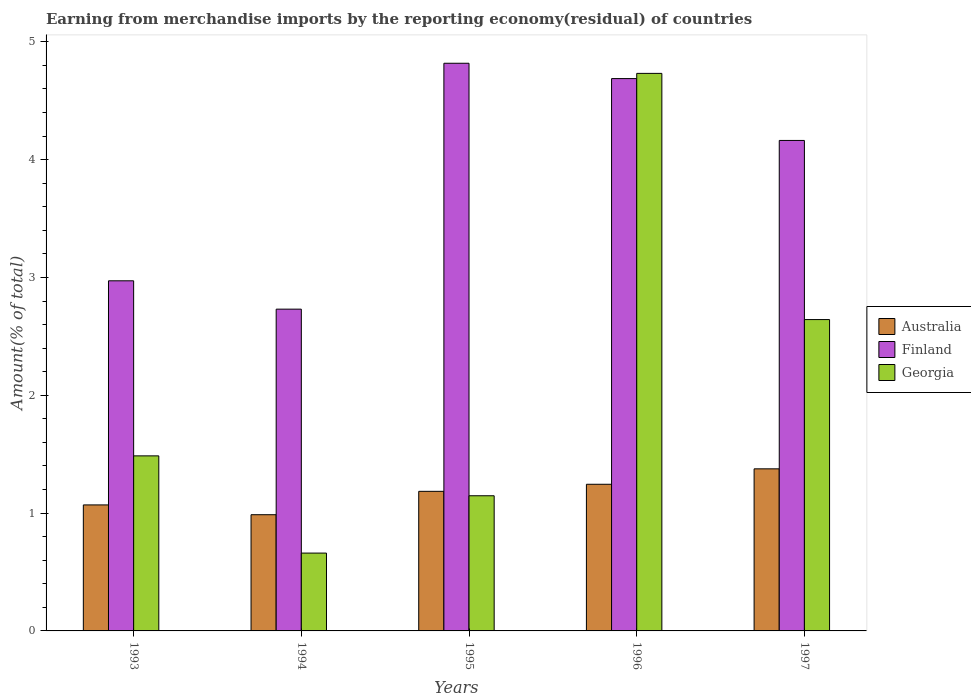How many groups of bars are there?
Your answer should be compact. 5. Are the number of bars per tick equal to the number of legend labels?
Make the answer very short. Yes. How many bars are there on the 1st tick from the left?
Your answer should be very brief. 3. How many bars are there on the 5th tick from the right?
Your response must be concise. 3. What is the percentage of amount earned from merchandise imports in Australia in 1996?
Provide a succinct answer. 1.24. Across all years, what is the maximum percentage of amount earned from merchandise imports in Georgia?
Offer a very short reply. 4.73. Across all years, what is the minimum percentage of amount earned from merchandise imports in Australia?
Offer a very short reply. 0.99. In which year was the percentage of amount earned from merchandise imports in Georgia maximum?
Offer a terse response. 1996. What is the total percentage of amount earned from merchandise imports in Finland in the graph?
Offer a very short reply. 19.37. What is the difference between the percentage of amount earned from merchandise imports in Georgia in 1995 and that in 1997?
Keep it short and to the point. -1.5. What is the difference between the percentage of amount earned from merchandise imports in Finland in 1993 and the percentage of amount earned from merchandise imports in Australia in 1994?
Keep it short and to the point. 1.99. What is the average percentage of amount earned from merchandise imports in Australia per year?
Provide a succinct answer. 1.17. In the year 1997, what is the difference between the percentage of amount earned from merchandise imports in Australia and percentage of amount earned from merchandise imports in Finland?
Give a very brief answer. -2.79. What is the ratio of the percentage of amount earned from merchandise imports in Finland in 1994 to that in 1996?
Make the answer very short. 0.58. Is the percentage of amount earned from merchandise imports in Australia in 1995 less than that in 1997?
Keep it short and to the point. Yes. Is the difference between the percentage of amount earned from merchandise imports in Australia in 1993 and 1996 greater than the difference between the percentage of amount earned from merchandise imports in Finland in 1993 and 1996?
Provide a succinct answer. Yes. What is the difference between the highest and the second highest percentage of amount earned from merchandise imports in Finland?
Keep it short and to the point. 0.13. What is the difference between the highest and the lowest percentage of amount earned from merchandise imports in Australia?
Offer a terse response. 0.39. In how many years, is the percentage of amount earned from merchandise imports in Georgia greater than the average percentage of amount earned from merchandise imports in Georgia taken over all years?
Make the answer very short. 2. What does the 1st bar from the right in 1997 represents?
Keep it short and to the point. Georgia. Is it the case that in every year, the sum of the percentage of amount earned from merchandise imports in Australia and percentage of amount earned from merchandise imports in Georgia is greater than the percentage of amount earned from merchandise imports in Finland?
Keep it short and to the point. No. How many bars are there?
Ensure brevity in your answer.  15. Are all the bars in the graph horizontal?
Make the answer very short. No. Are the values on the major ticks of Y-axis written in scientific E-notation?
Your response must be concise. No. Does the graph contain grids?
Your response must be concise. No. Where does the legend appear in the graph?
Provide a succinct answer. Center right. How many legend labels are there?
Provide a succinct answer. 3. How are the legend labels stacked?
Give a very brief answer. Vertical. What is the title of the graph?
Ensure brevity in your answer.  Earning from merchandise imports by the reporting economy(residual) of countries. Does "Cyprus" appear as one of the legend labels in the graph?
Keep it short and to the point. No. What is the label or title of the X-axis?
Make the answer very short. Years. What is the label or title of the Y-axis?
Your answer should be compact. Amount(% of total). What is the Amount(% of total) of Australia in 1993?
Ensure brevity in your answer.  1.07. What is the Amount(% of total) of Finland in 1993?
Ensure brevity in your answer.  2.97. What is the Amount(% of total) in Georgia in 1993?
Ensure brevity in your answer.  1.49. What is the Amount(% of total) in Australia in 1994?
Provide a succinct answer. 0.99. What is the Amount(% of total) of Finland in 1994?
Your answer should be compact. 2.73. What is the Amount(% of total) in Georgia in 1994?
Your response must be concise. 0.66. What is the Amount(% of total) of Australia in 1995?
Provide a short and direct response. 1.18. What is the Amount(% of total) of Finland in 1995?
Provide a short and direct response. 4.82. What is the Amount(% of total) of Georgia in 1995?
Offer a very short reply. 1.15. What is the Amount(% of total) in Australia in 1996?
Your answer should be compact. 1.24. What is the Amount(% of total) of Finland in 1996?
Offer a terse response. 4.69. What is the Amount(% of total) in Georgia in 1996?
Give a very brief answer. 4.73. What is the Amount(% of total) in Australia in 1997?
Offer a terse response. 1.38. What is the Amount(% of total) in Finland in 1997?
Ensure brevity in your answer.  4.16. What is the Amount(% of total) in Georgia in 1997?
Give a very brief answer. 2.64. Across all years, what is the maximum Amount(% of total) in Australia?
Give a very brief answer. 1.38. Across all years, what is the maximum Amount(% of total) of Finland?
Ensure brevity in your answer.  4.82. Across all years, what is the maximum Amount(% of total) in Georgia?
Your answer should be compact. 4.73. Across all years, what is the minimum Amount(% of total) in Australia?
Provide a succinct answer. 0.99. Across all years, what is the minimum Amount(% of total) of Finland?
Offer a very short reply. 2.73. Across all years, what is the minimum Amount(% of total) in Georgia?
Your response must be concise. 0.66. What is the total Amount(% of total) in Australia in the graph?
Your answer should be compact. 5.86. What is the total Amount(% of total) in Finland in the graph?
Offer a terse response. 19.37. What is the total Amount(% of total) of Georgia in the graph?
Your answer should be compact. 10.67. What is the difference between the Amount(% of total) in Australia in 1993 and that in 1994?
Give a very brief answer. 0.08. What is the difference between the Amount(% of total) in Finland in 1993 and that in 1994?
Offer a very short reply. 0.24. What is the difference between the Amount(% of total) of Georgia in 1993 and that in 1994?
Your answer should be very brief. 0.83. What is the difference between the Amount(% of total) of Australia in 1993 and that in 1995?
Offer a terse response. -0.12. What is the difference between the Amount(% of total) in Finland in 1993 and that in 1995?
Provide a succinct answer. -1.85. What is the difference between the Amount(% of total) in Georgia in 1993 and that in 1995?
Provide a short and direct response. 0.34. What is the difference between the Amount(% of total) of Australia in 1993 and that in 1996?
Make the answer very short. -0.18. What is the difference between the Amount(% of total) of Finland in 1993 and that in 1996?
Your answer should be compact. -1.72. What is the difference between the Amount(% of total) in Georgia in 1993 and that in 1996?
Your answer should be compact. -3.25. What is the difference between the Amount(% of total) in Australia in 1993 and that in 1997?
Make the answer very short. -0.31. What is the difference between the Amount(% of total) in Finland in 1993 and that in 1997?
Your answer should be very brief. -1.19. What is the difference between the Amount(% of total) of Georgia in 1993 and that in 1997?
Your answer should be compact. -1.16. What is the difference between the Amount(% of total) in Australia in 1994 and that in 1995?
Provide a short and direct response. -0.2. What is the difference between the Amount(% of total) in Finland in 1994 and that in 1995?
Ensure brevity in your answer.  -2.09. What is the difference between the Amount(% of total) in Georgia in 1994 and that in 1995?
Keep it short and to the point. -0.49. What is the difference between the Amount(% of total) in Australia in 1994 and that in 1996?
Your answer should be compact. -0.26. What is the difference between the Amount(% of total) in Finland in 1994 and that in 1996?
Keep it short and to the point. -1.96. What is the difference between the Amount(% of total) of Georgia in 1994 and that in 1996?
Provide a succinct answer. -4.07. What is the difference between the Amount(% of total) in Australia in 1994 and that in 1997?
Keep it short and to the point. -0.39. What is the difference between the Amount(% of total) in Finland in 1994 and that in 1997?
Your response must be concise. -1.43. What is the difference between the Amount(% of total) of Georgia in 1994 and that in 1997?
Offer a very short reply. -1.98. What is the difference between the Amount(% of total) in Australia in 1995 and that in 1996?
Ensure brevity in your answer.  -0.06. What is the difference between the Amount(% of total) of Finland in 1995 and that in 1996?
Your response must be concise. 0.13. What is the difference between the Amount(% of total) in Georgia in 1995 and that in 1996?
Provide a short and direct response. -3.58. What is the difference between the Amount(% of total) of Australia in 1995 and that in 1997?
Ensure brevity in your answer.  -0.19. What is the difference between the Amount(% of total) of Finland in 1995 and that in 1997?
Offer a very short reply. 0.66. What is the difference between the Amount(% of total) of Georgia in 1995 and that in 1997?
Offer a very short reply. -1.5. What is the difference between the Amount(% of total) in Australia in 1996 and that in 1997?
Offer a very short reply. -0.13. What is the difference between the Amount(% of total) in Finland in 1996 and that in 1997?
Your response must be concise. 0.53. What is the difference between the Amount(% of total) of Georgia in 1996 and that in 1997?
Offer a very short reply. 2.09. What is the difference between the Amount(% of total) of Australia in 1993 and the Amount(% of total) of Finland in 1994?
Offer a terse response. -1.66. What is the difference between the Amount(% of total) in Australia in 1993 and the Amount(% of total) in Georgia in 1994?
Keep it short and to the point. 0.41. What is the difference between the Amount(% of total) of Finland in 1993 and the Amount(% of total) of Georgia in 1994?
Keep it short and to the point. 2.31. What is the difference between the Amount(% of total) of Australia in 1993 and the Amount(% of total) of Finland in 1995?
Offer a very short reply. -3.75. What is the difference between the Amount(% of total) of Australia in 1993 and the Amount(% of total) of Georgia in 1995?
Ensure brevity in your answer.  -0.08. What is the difference between the Amount(% of total) in Finland in 1993 and the Amount(% of total) in Georgia in 1995?
Keep it short and to the point. 1.82. What is the difference between the Amount(% of total) of Australia in 1993 and the Amount(% of total) of Finland in 1996?
Make the answer very short. -3.62. What is the difference between the Amount(% of total) in Australia in 1993 and the Amount(% of total) in Georgia in 1996?
Offer a very short reply. -3.66. What is the difference between the Amount(% of total) in Finland in 1993 and the Amount(% of total) in Georgia in 1996?
Provide a succinct answer. -1.76. What is the difference between the Amount(% of total) in Australia in 1993 and the Amount(% of total) in Finland in 1997?
Provide a succinct answer. -3.09. What is the difference between the Amount(% of total) of Australia in 1993 and the Amount(% of total) of Georgia in 1997?
Provide a short and direct response. -1.57. What is the difference between the Amount(% of total) of Finland in 1993 and the Amount(% of total) of Georgia in 1997?
Offer a terse response. 0.33. What is the difference between the Amount(% of total) of Australia in 1994 and the Amount(% of total) of Finland in 1995?
Offer a terse response. -3.83. What is the difference between the Amount(% of total) in Australia in 1994 and the Amount(% of total) in Georgia in 1995?
Offer a very short reply. -0.16. What is the difference between the Amount(% of total) in Finland in 1994 and the Amount(% of total) in Georgia in 1995?
Give a very brief answer. 1.58. What is the difference between the Amount(% of total) in Australia in 1994 and the Amount(% of total) in Finland in 1996?
Offer a very short reply. -3.7. What is the difference between the Amount(% of total) in Australia in 1994 and the Amount(% of total) in Georgia in 1996?
Provide a succinct answer. -3.75. What is the difference between the Amount(% of total) of Finland in 1994 and the Amount(% of total) of Georgia in 1996?
Make the answer very short. -2. What is the difference between the Amount(% of total) of Australia in 1994 and the Amount(% of total) of Finland in 1997?
Offer a very short reply. -3.18. What is the difference between the Amount(% of total) in Australia in 1994 and the Amount(% of total) in Georgia in 1997?
Ensure brevity in your answer.  -1.66. What is the difference between the Amount(% of total) in Finland in 1994 and the Amount(% of total) in Georgia in 1997?
Your answer should be very brief. 0.09. What is the difference between the Amount(% of total) of Australia in 1995 and the Amount(% of total) of Finland in 1996?
Make the answer very short. -3.5. What is the difference between the Amount(% of total) of Australia in 1995 and the Amount(% of total) of Georgia in 1996?
Ensure brevity in your answer.  -3.55. What is the difference between the Amount(% of total) of Finland in 1995 and the Amount(% of total) of Georgia in 1996?
Provide a short and direct response. 0.09. What is the difference between the Amount(% of total) of Australia in 1995 and the Amount(% of total) of Finland in 1997?
Your answer should be very brief. -2.98. What is the difference between the Amount(% of total) in Australia in 1995 and the Amount(% of total) in Georgia in 1997?
Give a very brief answer. -1.46. What is the difference between the Amount(% of total) in Finland in 1995 and the Amount(% of total) in Georgia in 1997?
Offer a terse response. 2.18. What is the difference between the Amount(% of total) in Australia in 1996 and the Amount(% of total) in Finland in 1997?
Give a very brief answer. -2.92. What is the difference between the Amount(% of total) in Australia in 1996 and the Amount(% of total) in Georgia in 1997?
Give a very brief answer. -1.4. What is the difference between the Amount(% of total) in Finland in 1996 and the Amount(% of total) in Georgia in 1997?
Make the answer very short. 2.05. What is the average Amount(% of total) of Australia per year?
Offer a terse response. 1.17. What is the average Amount(% of total) in Finland per year?
Keep it short and to the point. 3.87. What is the average Amount(% of total) in Georgia per year?
Make the answer very short. 2.13. In the year 1993, what is the difference between the Amount(% of total) of Australia and Amount(% of total) of Finland?
Offer a very short reply. -1.9. In the year 1993, what is the difference between the Amount(% of total) in Australia and Amount(% of total) in Georgia?
Make the answer very short. -0.42. In the year 1993, what is the difference between the Amount(% of total) of Finland and Amount(% of total) of Georgia?
Your answer should be compact. 1.49. In the year 1994, what is the difference between the Amount(% of total) of Australia and Amount(% of total) of Finland?
Provide a succinct answer. -1.74. In the year 1994, what is the difference between the Amount(% of total) of Australia and Amount(% of total) of Georgia?
Your answer should be compact. 0.33. In the year 1994, what is the difference between the Amount(% of total) of Finland and Amount(% of total) of Georgia?
Keep it short and to the point. 2.07. In the year 1995, what is the difference between the Amount(% of total) in Australia and Amount(% of total) in Finland?
Provide a succinct answer. -3.63. In the year 1995, what is the difference between the Amount(% of total) in Australia and Amount(% of total) in Georgia?
Your answer should be compact. 0.04. In the year 1995, what is the difference between the Amount(% of total) of Finland and Amount(% of total) of Georgia?
Your answer should be very brief. 3.67. In the year 1996, what is the difference between the Amount(% of total) in Australia and Amount(% of total) in Finland?
Provide a short and direct response. -3.44. In the year 1996, what is the difference between the Amount(% of total) of Australia and Amount(% of total) of Georgia?
Keep it short and to the point. -3.49. In the year 1996, what is the difference between the Amount(% of total) in Finland and Amount(% of total) in Georgia?
Your answer should be very brief. -0.04. In the year 1997, what is the difference between the Amount(% of total) of Australia and Amount(% of total) of Finland?
Your response must be concise. -2.79. In the year 1997, what is the difference between the Amount(% of total) of Australia and Amount(% of total) of Georgia?
Provide a short and direct response. -1.27. In the year 1997, what is the difference between the Amount(% of total) in Finland and Amount(% of total) in Georgia?
Give a very brief answer. 1.52. What is the ratio of the Amount(% of total) in Australia in 1993 to that in 1994?
Offer a terse response. 1.08. What is the ratio of the Amount(% of total) of Finland in 1993 to that in 1994?
Offer a terse response. 1.09. What is the ratio of the Amount(% of total) in Georgia in 1993 to that in 1994?
Offer a very short reply. 2.25. What is the ratio of the Amount(% of total) in Australia in 1993 to that in 1995?
Ensure brevity in your answer.  0.9. What is the ratio of the Amount(% of total) in Finland in 1993 to that in 1995?
Ensure brevity in your answer.  0.62. What is the ratio of the Amount(% of total) in Georgia in 1993 to that in 1995?
Give a very brief answer. 1.29. What is the ratio of the Amount(% of total) of Australia in 1993 to that in 1996?
Your answer should be very brief. 0.86. What is the ratio of the Amount(% of total) of Finland in 1993 to that in 1996?
Give a very brief answer. 0.63. What is the ratio of the Amount(% of total) of Georgia in 1993 to that in 1996?
Ensure brevity in your answer.  0.31. What is the ratio of the Amount(% of total) in Australia in 1993 to that in 1997?
Ensure brevity in your answer.  0.78. What is the ratio of the Amount(% of total) of Finland in 1993 to that in 1997?
Give a very brief answer. 0.71. What is the ratio of the Amount(% of total) in Georgia in 1993 to that in 1997?
Offer a very short reply. 0.56. What is the ratio of the Amount(% of total) of Australia in 1994 to that in 1995?
Your answer should be compact. 0.83. What is the ratio of the Amount(% of total) of Finland in 1994 to that in 1995?
Provide a short and direct response. 0.57. What is the ratio of the Amount(% of total) of Georgia in 1994 to that in 1995?
Offer a very short reply. 0.58. What is the ratio of the Amount(% of total) in Australia in 1994 to that in 1996?
Offer a terse response. 0.79. What is the ratio of the Amount(% of total) of Finland in 1994 to that in 1996?
Provide a short and direct response. 0.58. What is the ratio of the Amount(% of total) of Georgia in 1994 to that in 1996?
Give a very brief answer. 0.14. What is the ratio of the Amount(% of total) in Australia in 1994 to that in 1997?
Make the answer very short. 0.72. What is the ratio of the Amount(% of total) in Finland in 1994 to that in 1997?
Your response must be concise. 0.66. What is the ratio of the Amount(% of total) in Georgia in 1994 to that in 1997?
Your answer should be very brief. 0.25. What is the ratio of the Amount(% of total) in Australia in 1995 to that in 1996?
Your response must be concise. 0.95. What is the ratio of the Amount(% of total) of Finland in 1995 to that in 1996?
Give a very brief answer. 1.03. What is the ratio of the Amount(% of total) of Georgia in 1995 to that in 1996?
Your answer should be very brief. 0.24. What is the ratio of the Amount(% of total) of Australia in 1995 to that in 1997?
Give a very brief answer. 0.86. What is the ratio of the Amount(% of total) in Finland in 1995 to that in 1997?
Your answer should be very brief. 1.16. What is the ratio of the Amount(% of total) of Georgia in 1995 to that in 1997?
Ensure brevity in your answer.  0.43. What is the ratio of the Amount(% of total) of Australia in 1996 to that in 1997?
Make the answer very short. 0.9. What is the ratio of the Amount(% of total) in Finland in 1996 to that in 1997?
Your response must be concise. 1.13. What is the ratio of the Amount(% of total) of Georgia in 1996 to that in 1997?
Make the answer very short. 1.79. What is the difference between the highest and the second highest Amount(% of total) in Australia?
Offer a terse response. 0.13. What is the difference between the highest and the second highest Amount(% of total) in Finland?
Offer a very short reply. 0.13. What is the difference between the highest and the second highest Amount(% of total) of Georgia?
Your answer should be compact. 2.09. What is the difference between the highest and the lowest Amount(% of total) in Australia?
Your answer should be very brief. 0.39. What is the difference between the highest and the lowest Amount(% of total) of Finland?
Provide a short and direct response. 2.09. What is the difference between the highest and the lowest Amount(% of total) in Georgia?
Your answer should be compact. 4.07. 